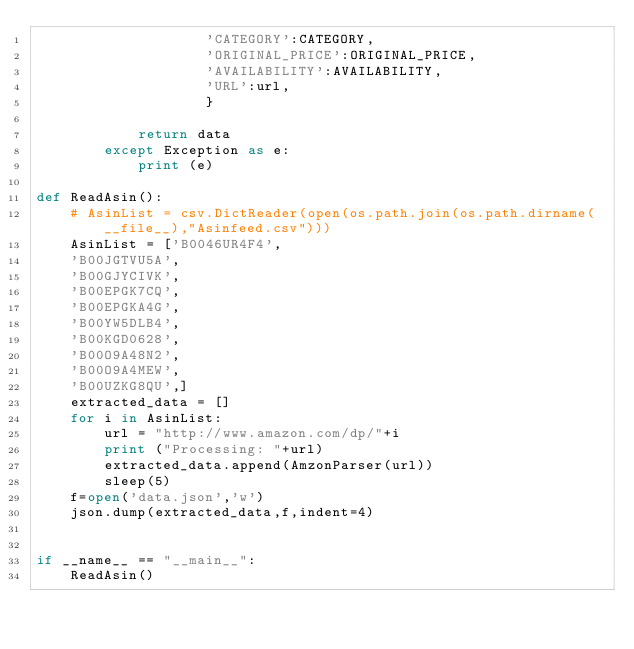Convert code to text. <code><loc_0><loc_0><loc_500><loc_500><_Python_>                    'CATEGORY':CATEGORY,
                    'ORIGINAL_PRICE':ORIGINAL_PRICE,
                    'AVAILABILITY':AVAILABILITY,
                    'URL':url,
                    }
 
            return data
        except Exception as e:
            print (e)
 
def ReadAsin():
    # AsinList = csv.DictReader(open(os.path.join(os.path.dirname(__file__),"Asinfeed.csv")))
    AsinList = ['B0046UR4F4',
    'B00JGTVU5A',
    'B00GJYCIVK',
    'B00EPGK7CQ',
    'B00EPGKA4G',
    'B00YW5DLB4',
    'B00KGD0628',
    'B00O9A48N2',
    'B00O9A4MEW',
    'B00UZKG8QU',]
    extracted_data = []
    for i in AsinList:
        url = "http://www.amazon.com/dp/"+i
        print ("Processing: "+url)
        extracted_data.append(AmzonParser(url))
        sleep(5)
    f=open('data.json','w')
    json.dump(extracted_data,f,indent=4)
 
 
if __name__ == "__main__":
    ReadAsin()
</code> 